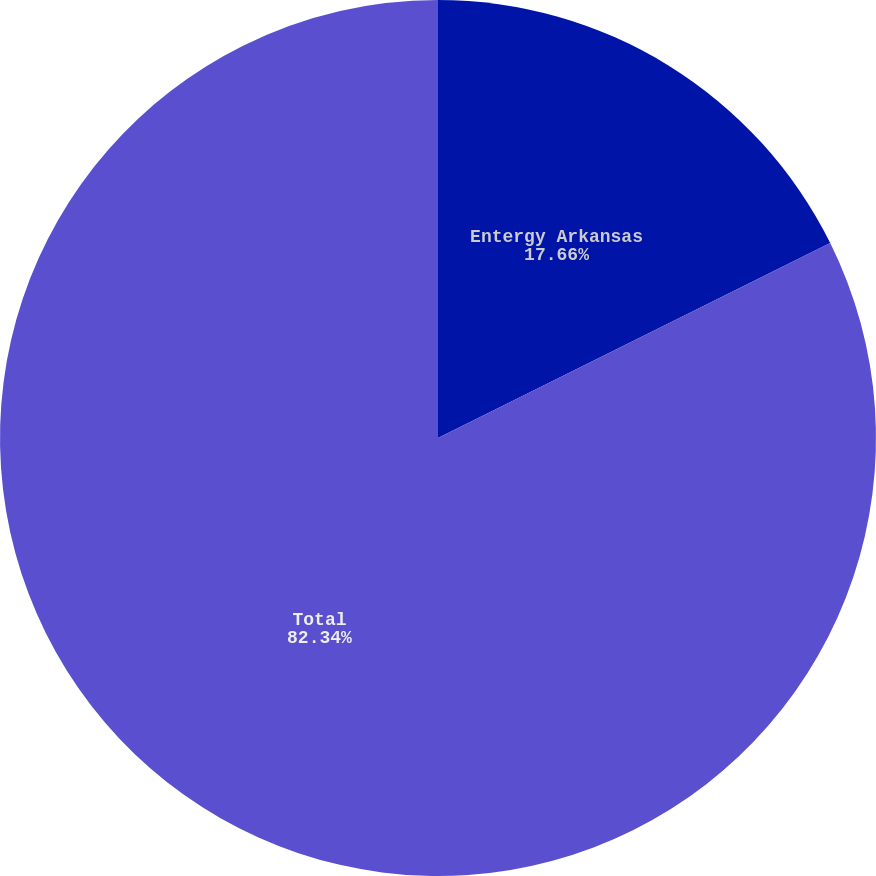Convert chart. <chart><loc_0><loc_0><loc_500><loc_500><pie_chart><fcel>Entergy Arkansas<fcel>Total<nl><fcel>17.66%<fcel>82.34%<nl></chart> 